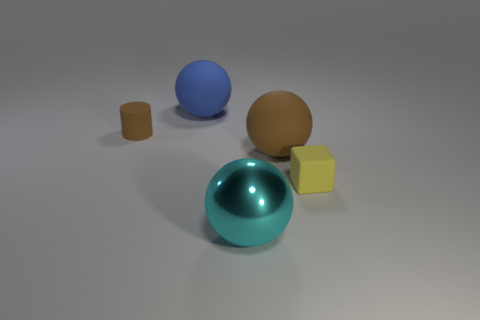Is the number of tiny matte cylinders in front of the large cyan thing greater than the number of metal objects? Upon inspecting the image, it appears there is only one tiny matte cylinder and no discernible metal objects. Therefore, the number of tiny matte cylinders is not greater than the number of metal objects, since there are none, making the count of metal objects zero. 